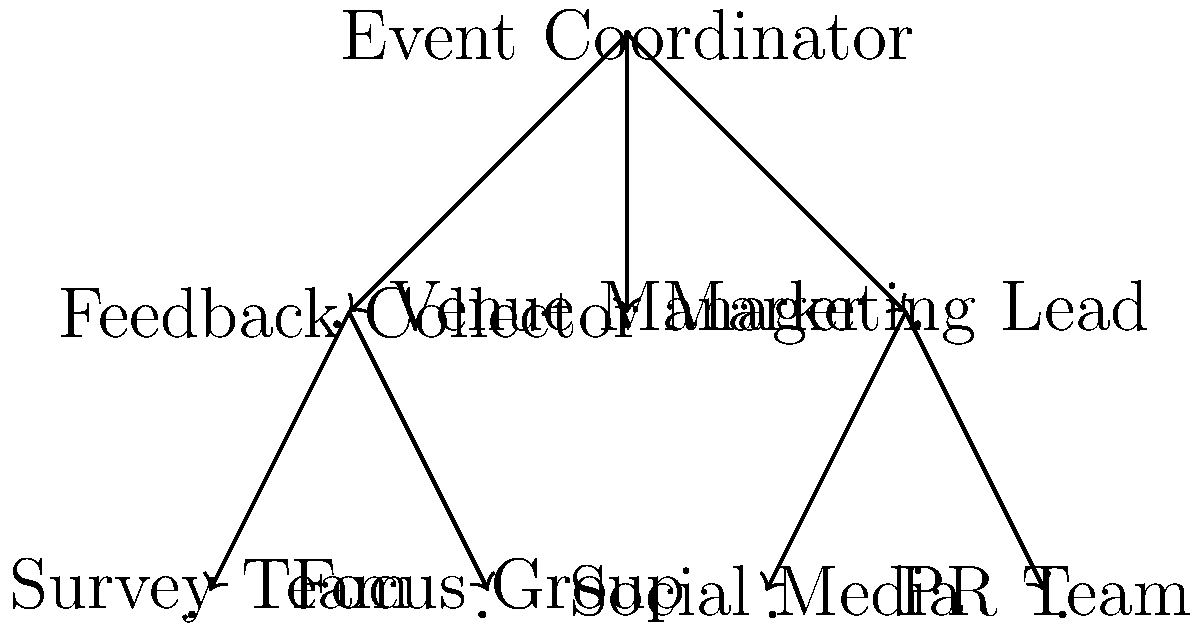In the organizational chart above, which subgroup forms a non-trivial normal subgroup of the entire community organization? To determine the non-trivial normal subgroup, we need to follow these steps:

1. Identify the subgroups in the organizational chart:
   - Event Coordinator (EC)
   - Feedback Collector (FC) with Survey Team (ST) and Focus Group (FG)
   - Venue Manager (VM)
   - Marketing Lead (ML) with Social Media (SM) and PR Team (PR)

2. A normal subgroup must be closed under conjugation by any element of the larger group. In this context, it means that the subgroup's responsibilities should be consistent regardless of who oversees them.

3. The Feedback Collector subgroup (FC, ST, FG) forms a non-trivial normal subgroup because:
   a) It's a proper subset of the entire organization (non-trivial).
   b) Its function (collecting feedback) remains consistent regardless of who manages it (normal).
   c) It doesn't interfere with other subgroups' functions.

4. The Marketing Lead subgroup (ML, SM, PR) is not a normal subgroup because its functions may overlap or interfere with other roles, especially the Event Coordinator.

5. The Venue Manager doesn't form a subgroup as it's a single element.

Therefore, the Feedback Collector subgroup (FC, ST, FG) is the non-trivial normal subgroup of the entire community organization.
Answer: Feedback Collector subgroup (Feedback Collector, Survey Team, Focus Group) 